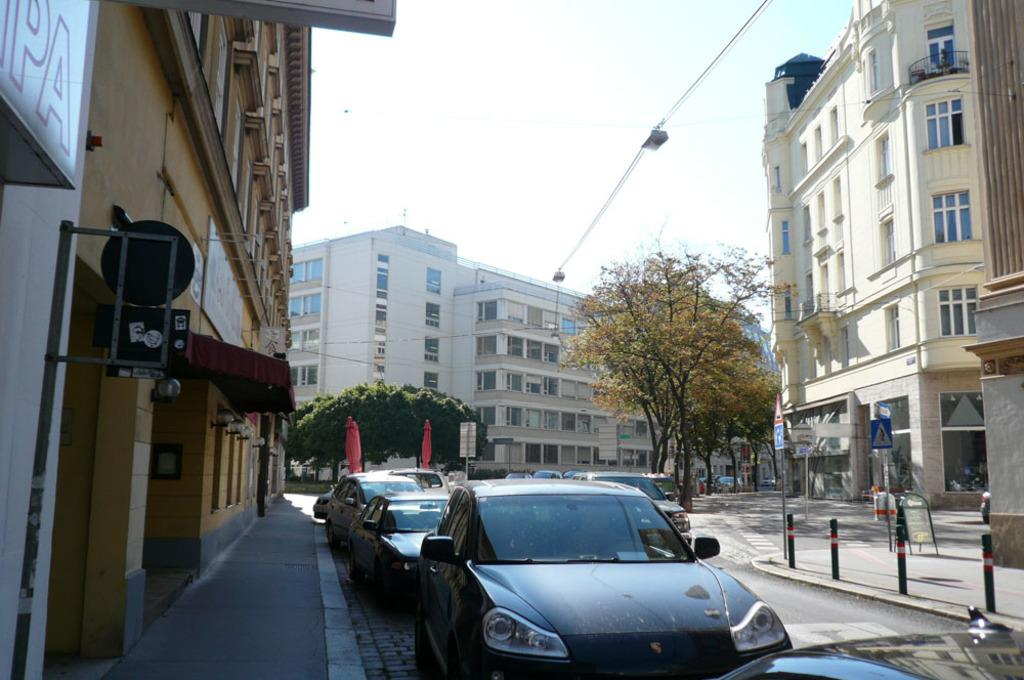What can be seen at the bottom of the image? There are cars on the road at the bottom of the image. What structures are present on both sides of the image? There are buildings on either side of the image. What type of vegetation is visible at the back of the image? There are trees at the back side of the image. What is visible at the top of the image? The sky is visible at the top of the image. How many lizards are climbing the buildings in the image? There are no lizards present in the image; it only features cars, buildings, trees, and the sky. What division is responsible for maintaining the roads in the image? The image does not provide information about the division responsible for maintaining the roads. 